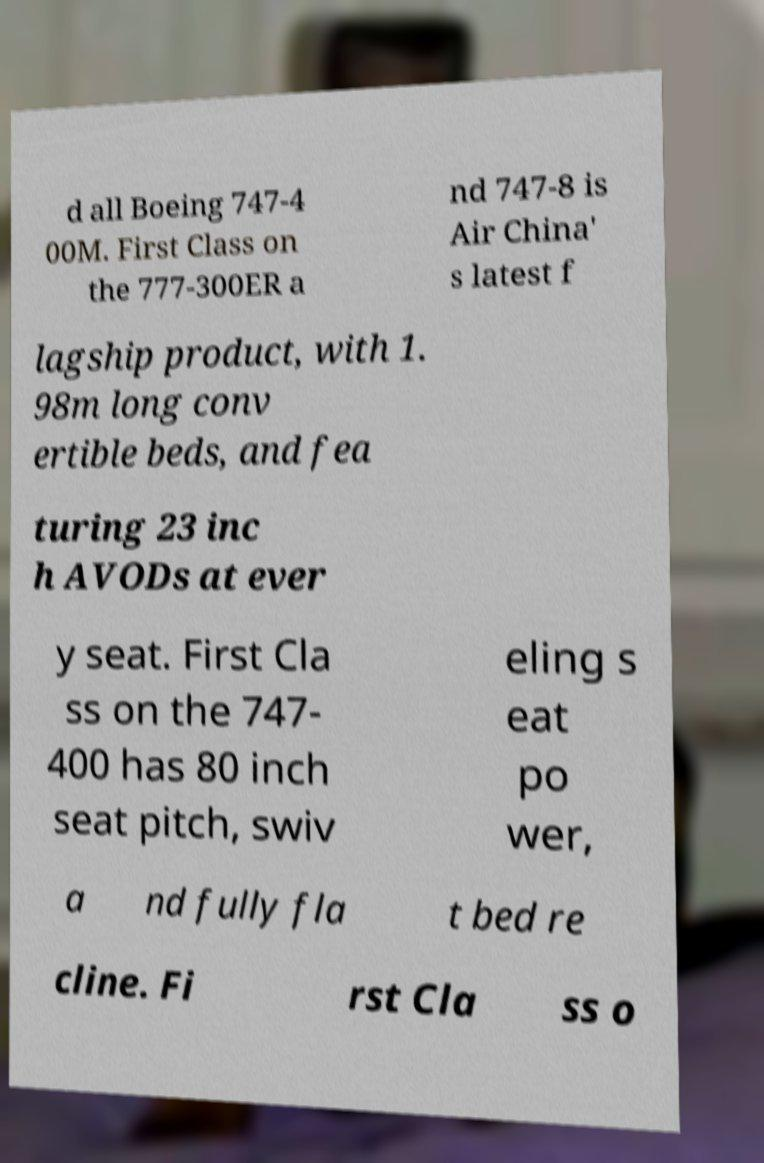I need the written content from this picture converted into text. Can you do that? d all Boeing 747-4 00M. First Class on the 777-300ER a nd 747-8 is Air China' s latest f lagship product, with 1. 98m long conv ertible beds, and fea turing 23 inc h AVODs at ever y seat. First Cla ss on the 747- 400 has 80 inch seat pitch, swiv eling s eat po wer, a nd fully fla t bed re cline. Fi rst Cla ss o 